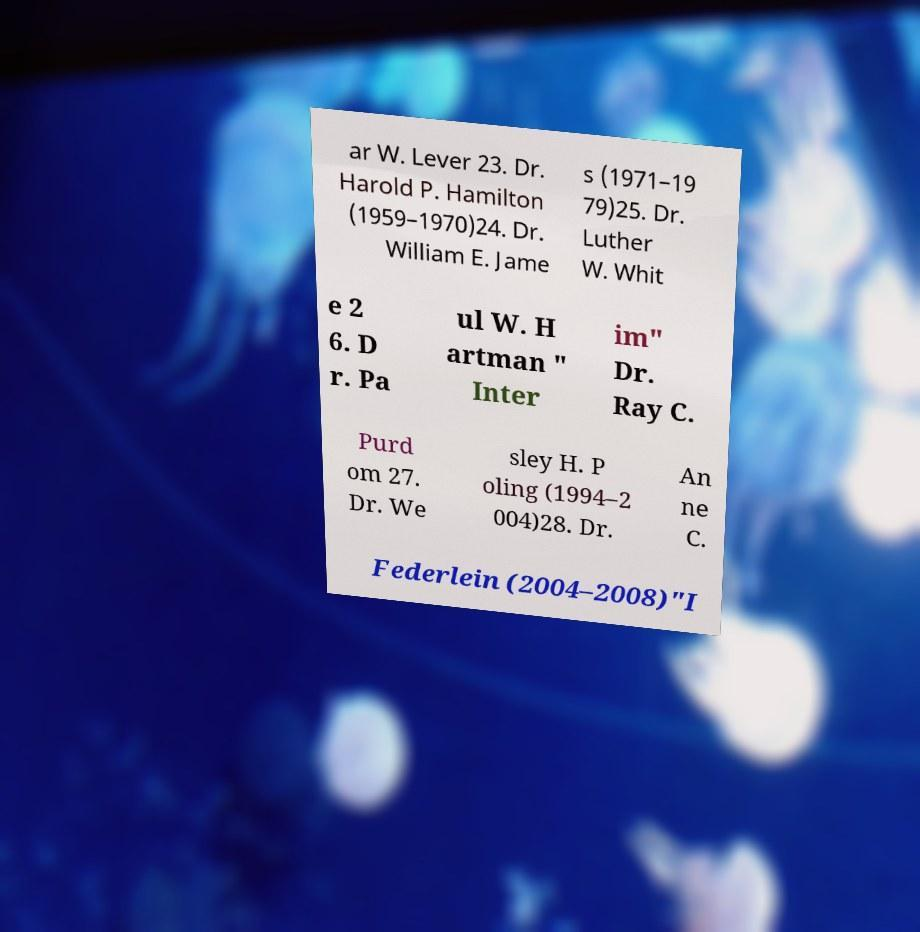There's text embedded in this image that I need extracted. Can you transcribe it verbatim? ar W. Lever 23. Dr. Harold P. Hamilton (1959–1970)24. Dr. William E. Jame s (1971–19 79)25. Dr. Luther W. Whit e 2 6. D r. Pa ul W. H artman " Inter im" Dr. Ray C. Purd om 27. Dr. We sley H. P oling (1994–2 004)28. Dr. An ne C. Federlein (2004–2008)"I 